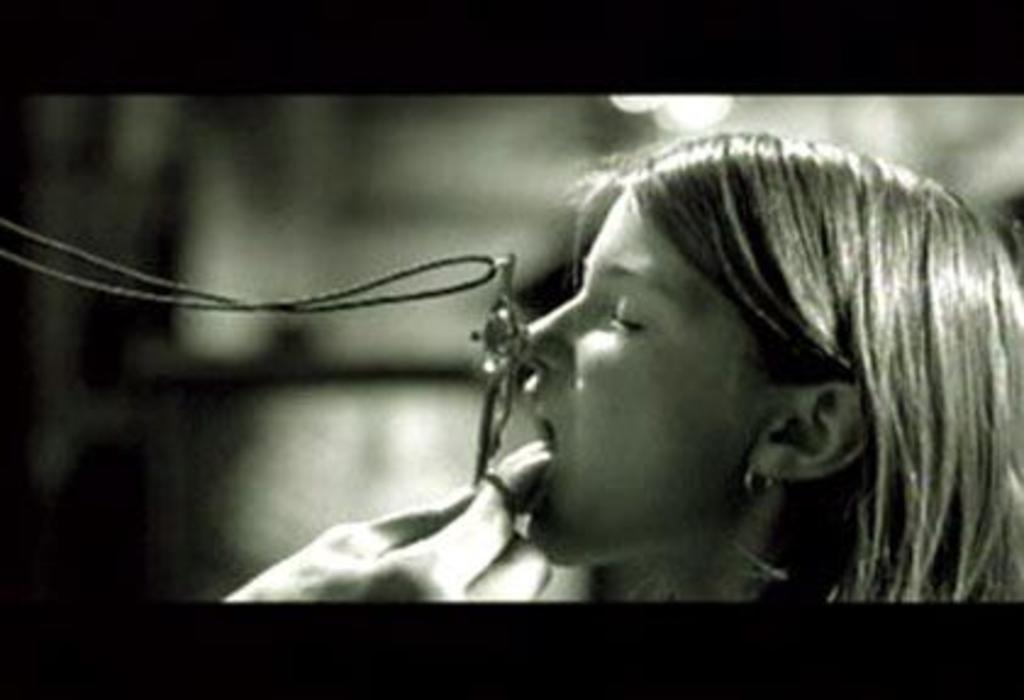Who is the main subject in the image? There is a woman in the image. What can be observed about the background of the image? The background of the image is blurred. What type of authority does the woman have in the image? There is no indication of any authority in the image, as it only features a woman and a blurred background. How many spiders can be seen crawling on the woman in the image? There are no spiders present in the image. 